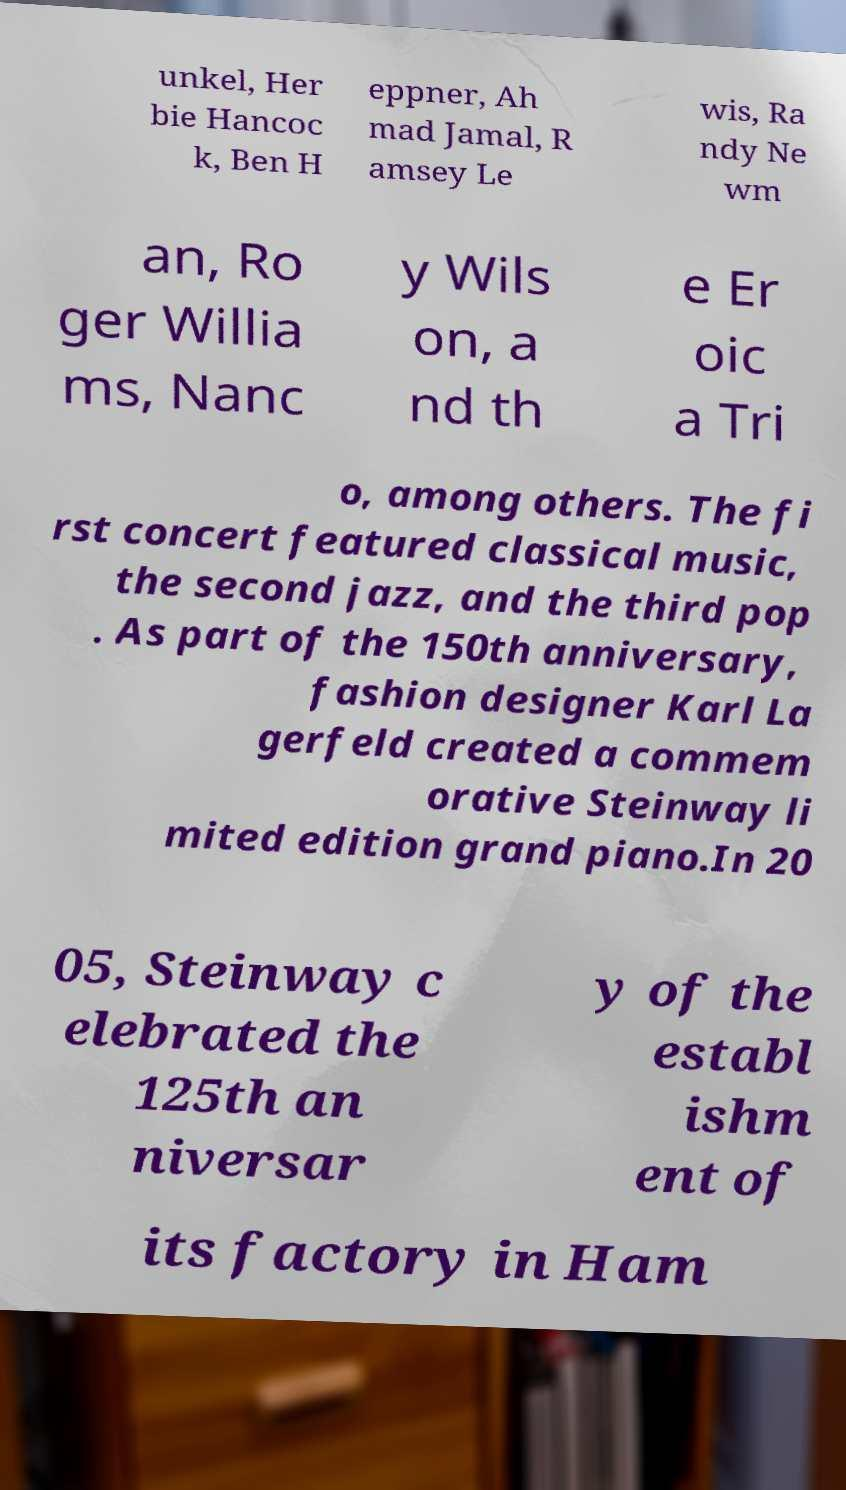For documentation purposes, I need the text within this image transcribed. Could you provide that? unkel, Her bie Hancoc k, Ben H eppner, Ah mad Jamal, R amsey Le wis, Ra ndy Ne wm an, Ro ger Willia ms, Nanc y Wils on, a nd th e Er oic a Tri o, among others. The fi rst concert featured classical music, the second jazz, and the third pop . As part of the 150th anniversary, fashion designer Karl La gerfeld created a commem orative Steinway li mited edition grand piano.In 20 05, Steinway c elebrated the 125th an niversar y of the establ ishm ent of its factory in Ham 